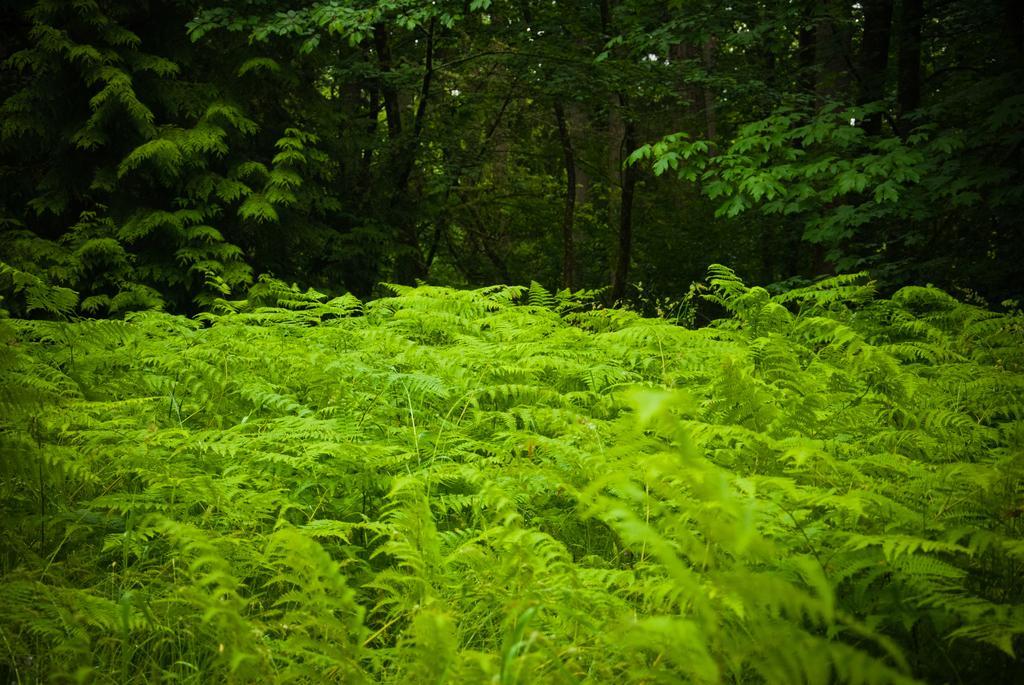Could you give a brief overview of what you see in this image? In this image I can see few trees which are green in color and in the background I can see few other trees which are green and brown in color. 